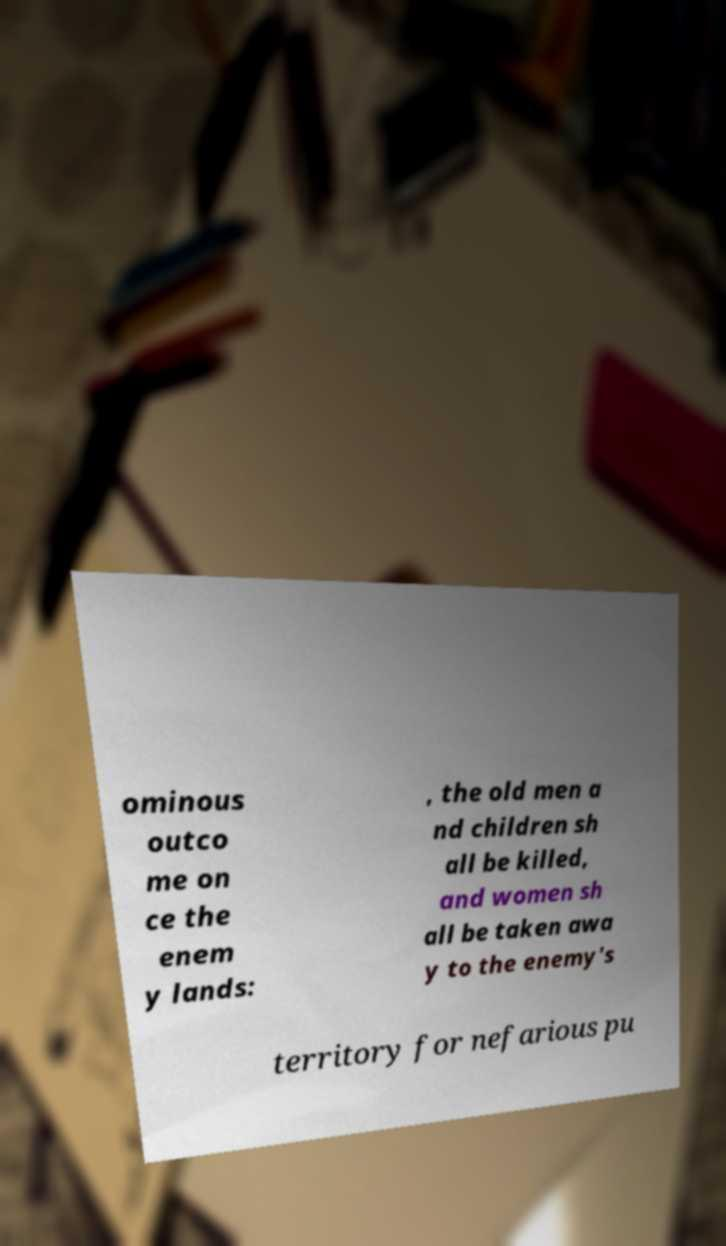There's text embedded in this image that I need extracted. Can you transcribe it verbatim? ominous outco me on ce the enem y lands: , the old men a nd children sh all be killed, and women sh all be taken awa y to the enemy's territory for nefarious pu 